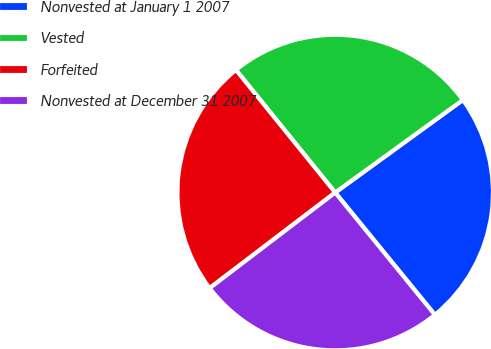<chart> <loc_0><loc_0><loc_500><loc_500><pie_chart><fcel>Nonvested at January 1 2007<fcel>Vested<fcel>Forfeited<fcel>Nonvested at December 31 2007<nl><fcel>24.1%<fcel>25.84%<fcel>24.53%<fcel>25.53%<nl></chart> 